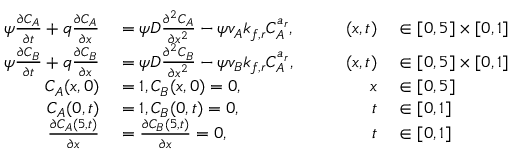Convert formula to latex. <formula><loc_0><loc_0><loc_500><loc_500>\begin{array} { r l r l } { \psi \frac { \partial C _ { A } } { \partial t } + q \frac { \partial C _ { A } } { \partial x } } & = \psi D \frac { \partial ^ { 2 } C _ { A } } { \partial x ^ { 2 } } - \psi v _ { A } k _ { f , r } C _ { A } ^ { a _ { r } } , \quad } & { ( x , t ) } & \in [ 0 , 5 ] \times [ 0 , 1 ] } \\ { \psi \frac { \partial C _ { B } } { \partial t } + q \frac { \partial C _ { B } } { \partial x } } & = \psi D \frac { \partial ^ { 2 } C _ { B } } { \partial x ^ { 2 } } - \psi v _ { B } k _ { f , r } C _ { A } ^ { a _ { r } } , \quad } & { ( x , t ) } & \in [ 0 , 5 ] \times [ 0 , 1 ] } \\ { C _ { A } ( x , 0 ) } & = 1 , C _ { B } ( x , 0 ) = 0 , } & { x } & \in [ 0 , 5 ] } \\ { C _ { A } ( 0 , t ) } & = 1 , C _ { B } ( 0 , t ) = 0 , } & { t } & \in [ 0 , 1 ] } \\ { \frac { \partial C _ { A } ( 5 , t ) } { \partial x } } & = \frac { \partial C _ { B } ( 5 , t ) } { \partial x } = 0 , } & { t } & \in [ 0 , 1 ] } \end{array}</formula> 